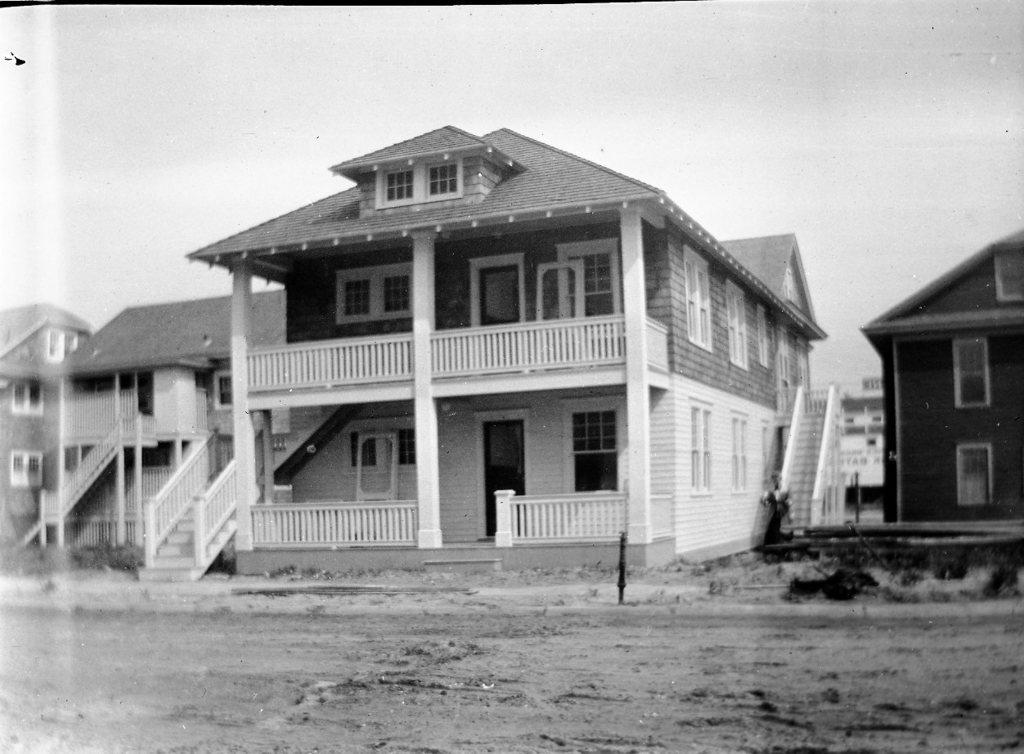What type of structures can be seen in the image? There are buildings in the image. Are there any architectural features visible in the image? Yes, there are stairs, a fence, doors, and windows visible in the image. What is visible at the top of the image? The sky is visible at the top of the image. How many rings are visible on the back of the building in the image? There are no rings visible on the back of the building in the image, as the provided facts do not mention any rings. 